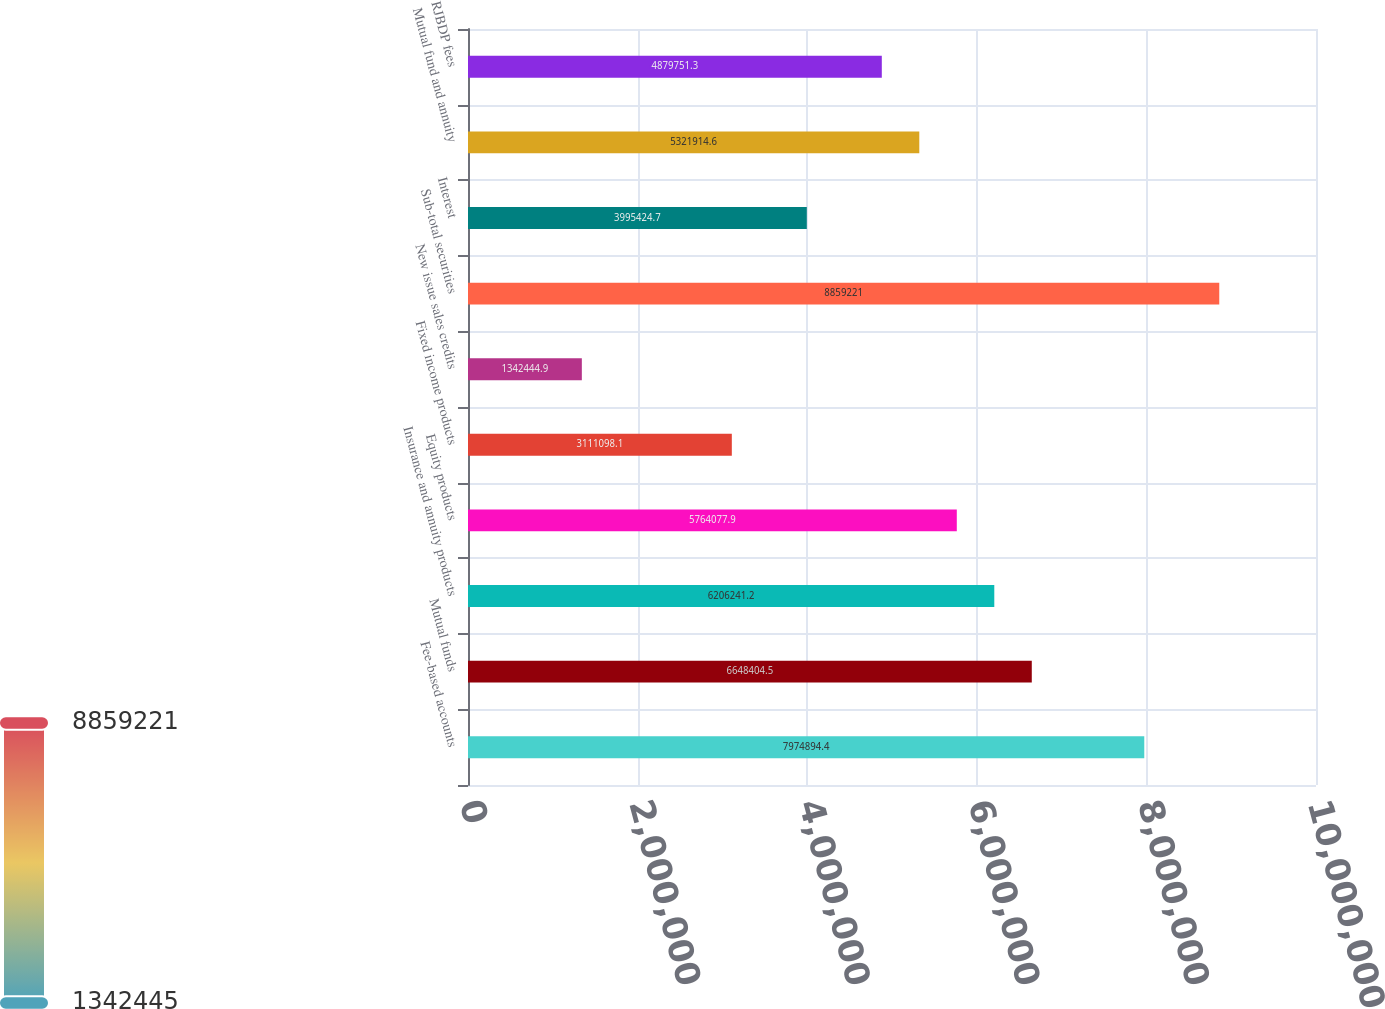Convert chart to OTSL. <chart><loc_0><loc_0><loc_500><loc_500><bar_chart><fcel>Fee-based accounts<fcel>Mutual funds<fcel>Insurance and annuity products<fcel>Equity products<fcel>Fixed income products<fcel>New issue sales credits<fcel>Sub-total securities<fcel>Interest<fcel>Mutual fund and annuity<fcel>RJBDP fees<nl><fcel>7.97489e+06<fcel>6.6484e+06<fcel>6.20624e+06<fcel>5.76408e+06<fcel>3.1111e+06<fcel>1.34244e+06<fcel>8.85922e+06<fcel>3.99542e+06<fcel>5.32191e+06<fcel>4.87975e+06<nl></chart> 